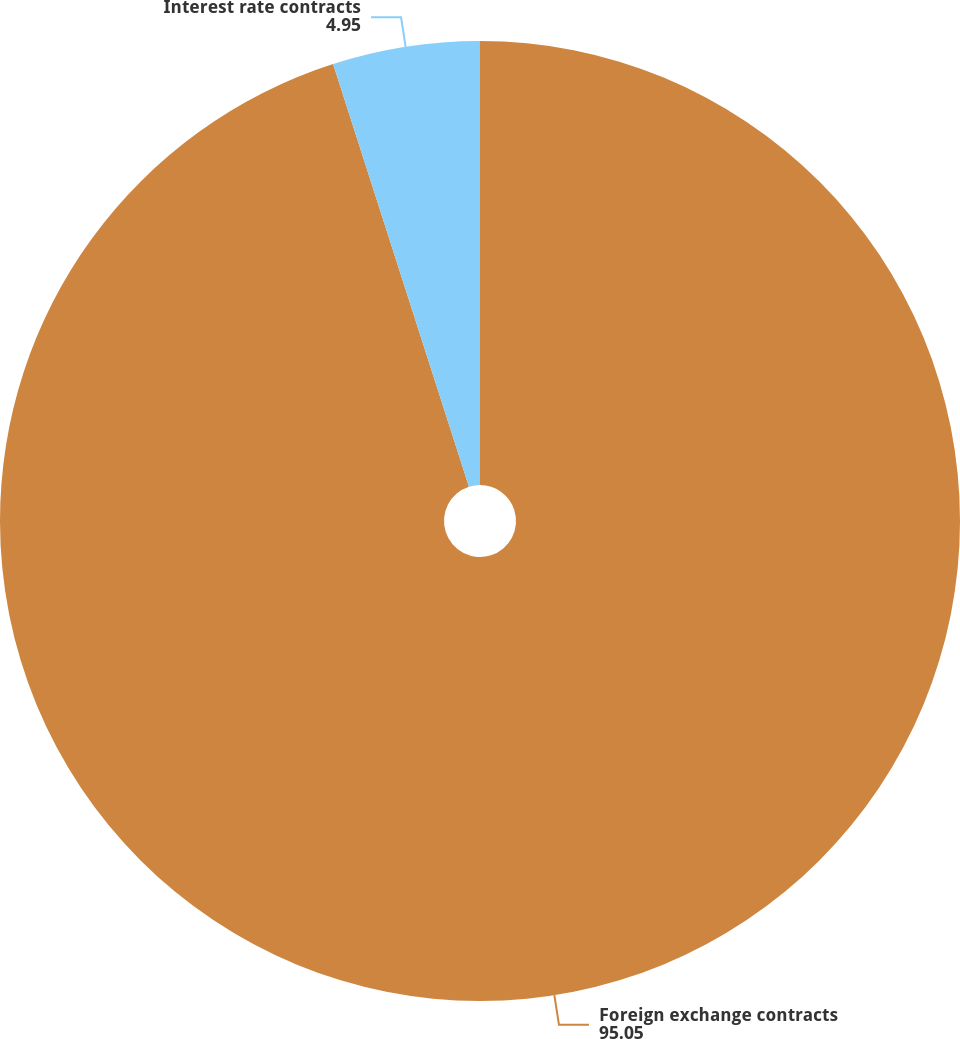Convert chart to OTSL. <chart><loc_0><loc_0><loc_500><loc_500><pie_chart><fcel>Foreign exchange contracts<fcel>Interest rate contracts<nl><fcel>95.05%<fcel>4.95%<nl></chart> 